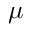<formula> <loc_0><loc_0><loc_500><loc_500>\mu</formula> 